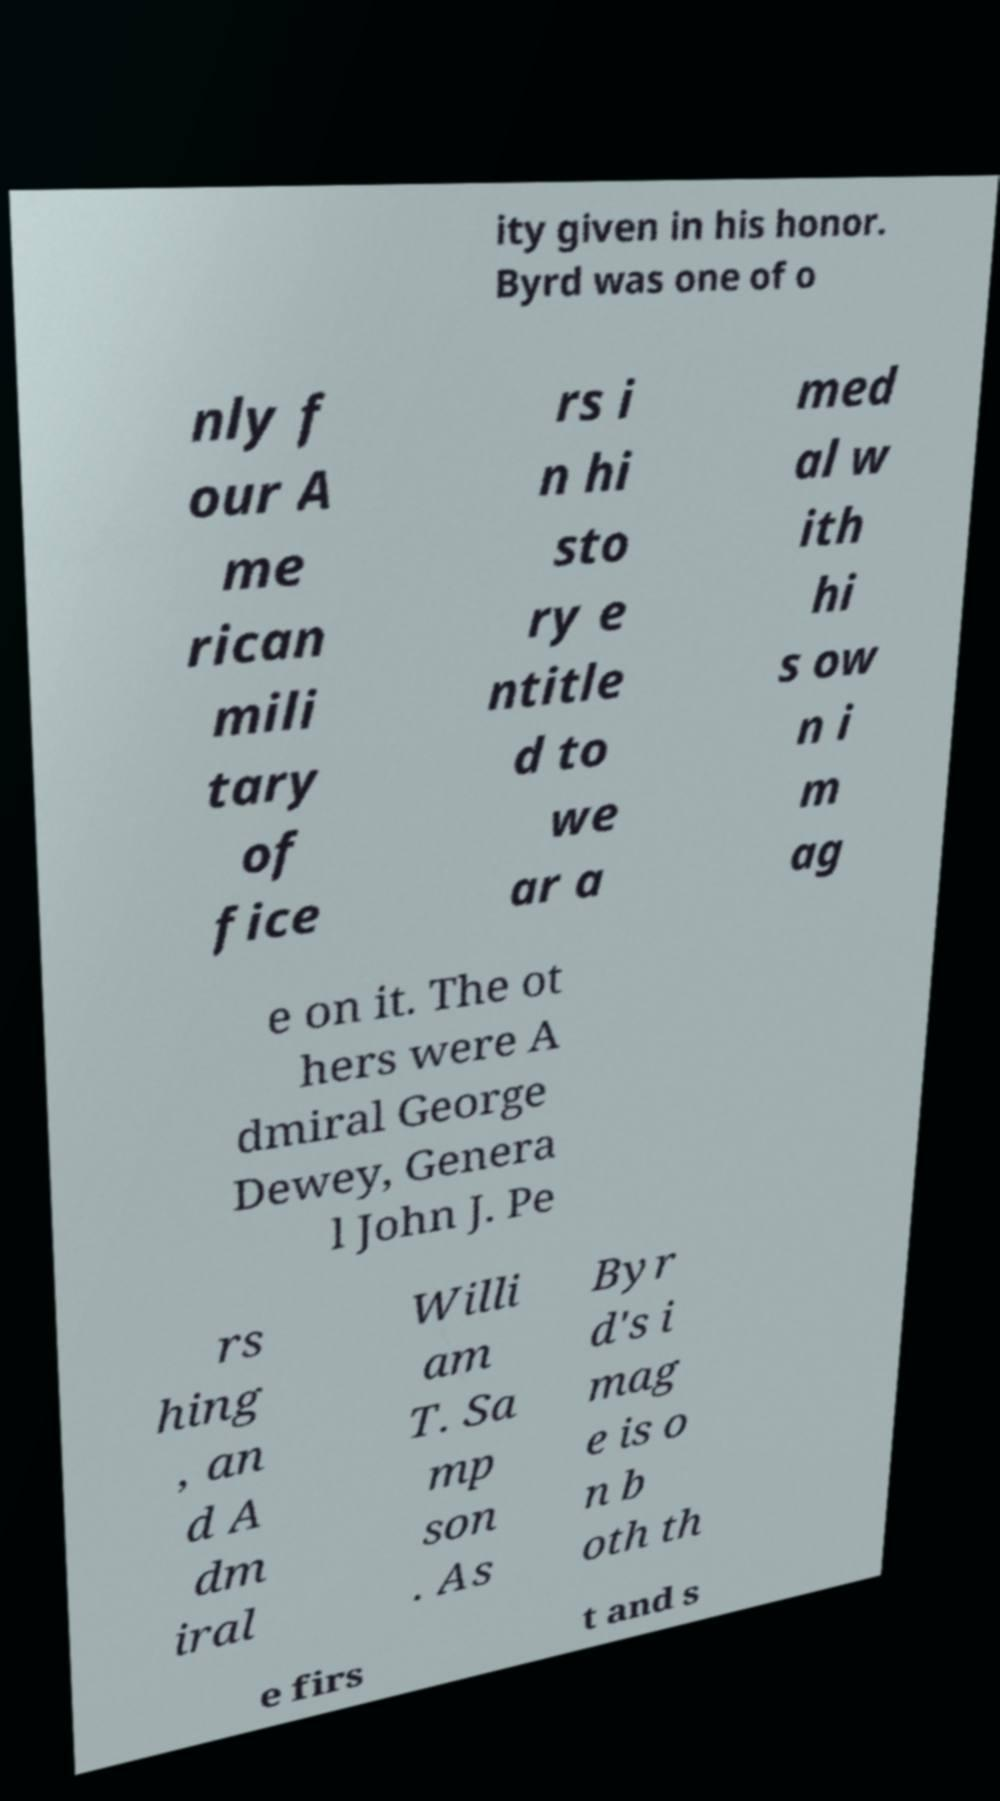Could you assist in decoding the text presented in this image and type it out clearly? ity given in his honor. Byrd was one of o nly f our A me rican mili tary of fice rs i n hi sto ry e ntitle d to we ar a med al w ith hi s ow n i m ag e on it. The ot hers were A dmiral George Dewey, Genera l John J. Pe rs hing , an d A dm iral Willi am T. Sa mp son . As Byr d's i mag e is o n b oth th e firs t and s 